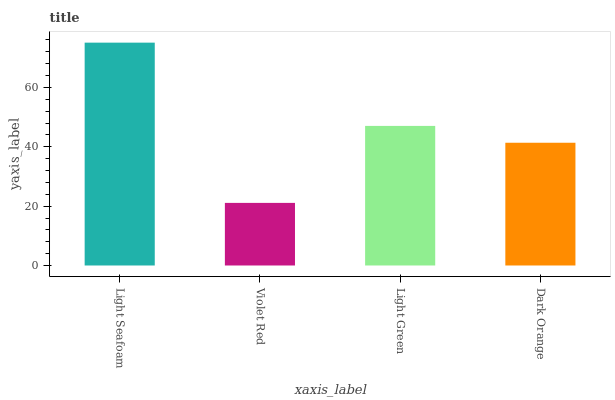Is Violet Red the minimum?
Answer yes or no. Yes. Is Light Seafoam the maximum?
Answer yes or no. Yes. Is Light Green the minimum?
Answer yes or no. No. Is Light Green the maximum?
Answer yes or no. No. Is Light Green greater than Violet Red?
Answer yes or no. Yes. Is Violet Red less than Light Green?
Answer yes or no. Yes. Is Violet Red greater than Light Green?
Answer yes or no. No. Is Light Green less than Violet Red?
Answer yes or no. No. Is Light Green the high median?
Answer yes or no. Yes. Is Dark Orange the low median?
Answer yes or no. Yes. Is Violet Red the high median?
Answer yes or no. No. Is Light Green the low median?
Answer yes or no. No. 